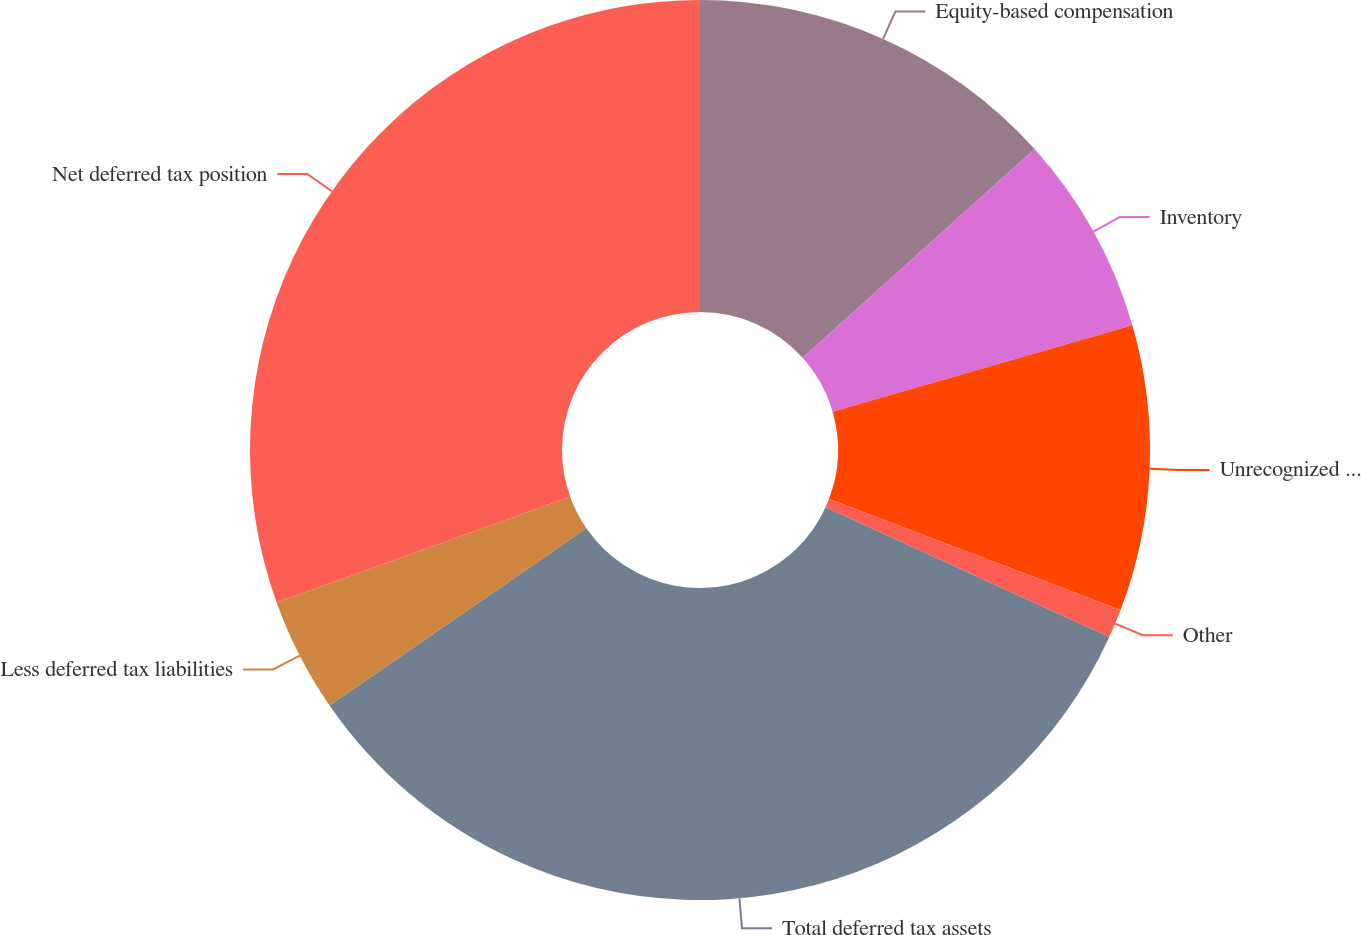Convert chart to OTSL. <chart><loc_0><loc_0><loc_500><loc_500><pie_chart><fcel>Equity-based compensation<fcel>Inventory<fcel>Unrecognized tax benefit<fcel>Other<fcel>Total deferred tax assets<fcel>Less deferred tax liabilities<fcel>Net deferred tax position<nl><fcel>13.34%<fcel>7.19%<fcel>10.26%<fcel>1.03%<fcel>33.57%<fcel>4.11%<fcel>30.5%<nl></chart> 